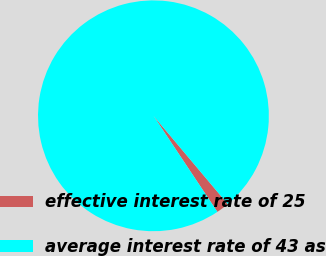<chart> <loc_0><loc_0><loc_500><loc_500><pie_chart><fcel>effective interest rate of 25<fcel>average interest rate of 43 as<nl><fcel>1.79%<fcel>98.21%<nl></chart> 